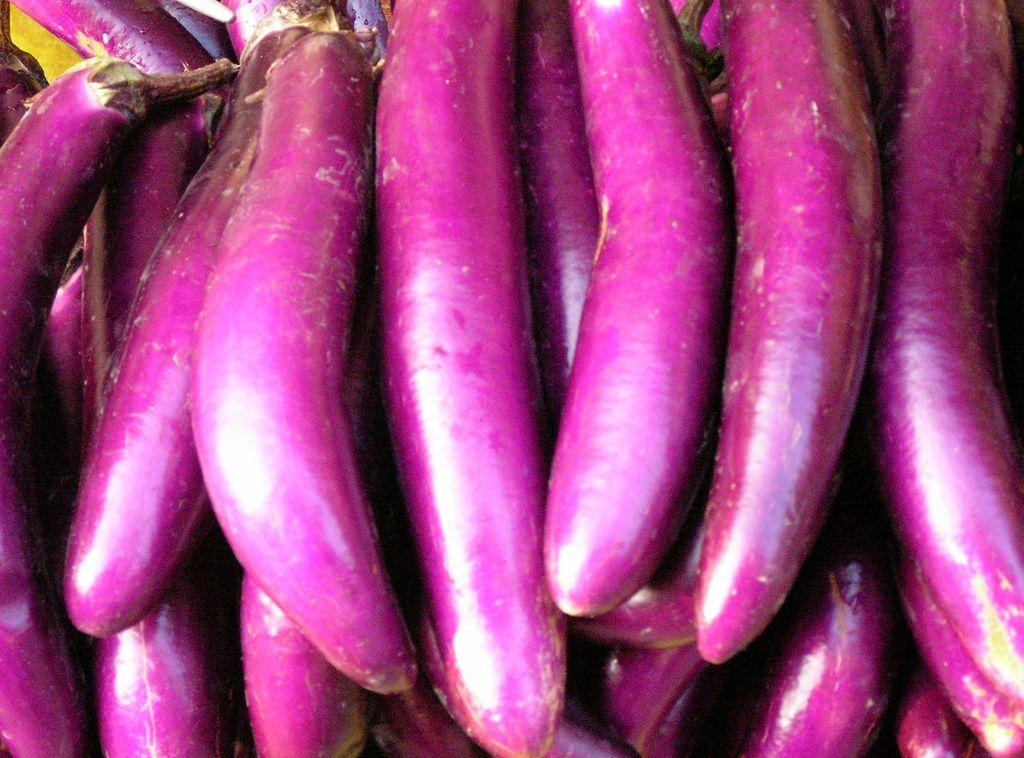What type of vegetable is present in the image? There are brinjals in the image. Can you describe the appearance of the brinjals? The brinjals appear to be fresh and have a dark purple color. Are the brinjals accompanied by any other vegetables or objects in the image? The image only shows brinjals. What type of drain is visible in the image? There is no drain present in the image; it only contains brinjals. What kind of coil can be seen wrapped around the brinjals in the image? There is no coil present in the image; it only contains brinjals. 